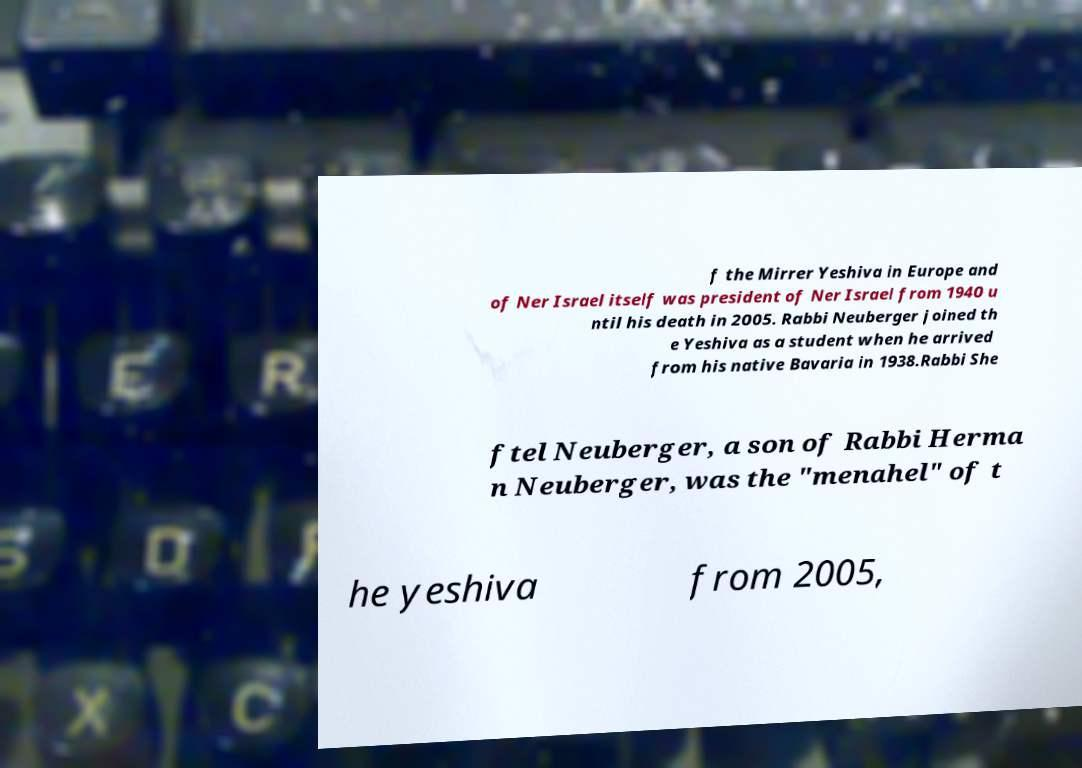What messages or text are displayed in this image? I need them in a readable, typed format. f the Mirrer Yeshiva in Europe and of Ner Israel itself was president of Ner Israel from 1940 u ntil his death in 2005. Rabbi Neuberger joined th e Yeshiva as a student when he arrived from his native Bavaria in 1938.Rabbi She ftel Neuberger, a son of Rabbi Herma n Neuberger, was the "menahel" of t he yeshiva from 2005, 